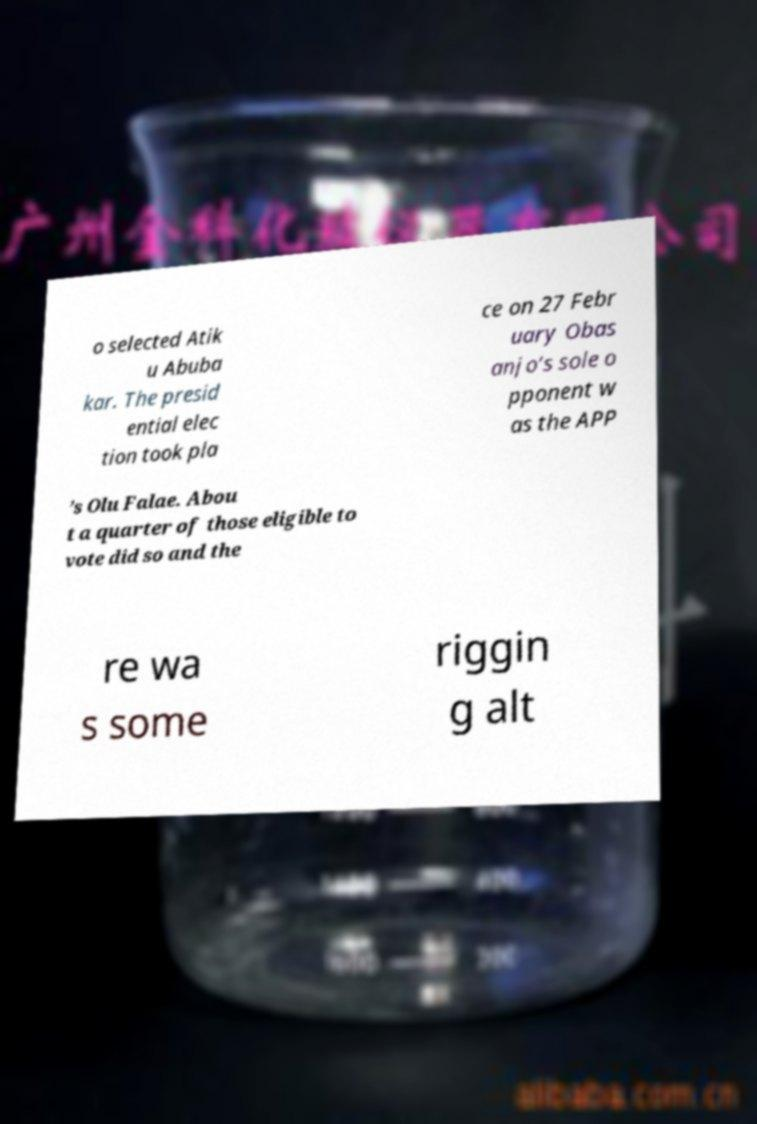For documentation purposes, I need the text within this image transcribed. Could you provide that? o selected Atik u Abuba kar. The presid ential elec tion took pla ce on 27 Febr uary Obas anjo’s sole o pponent w as the APP ’s Olu Falae. Abou t a quarter of those eligible to vote did so and the re wa s some riggin g alt 